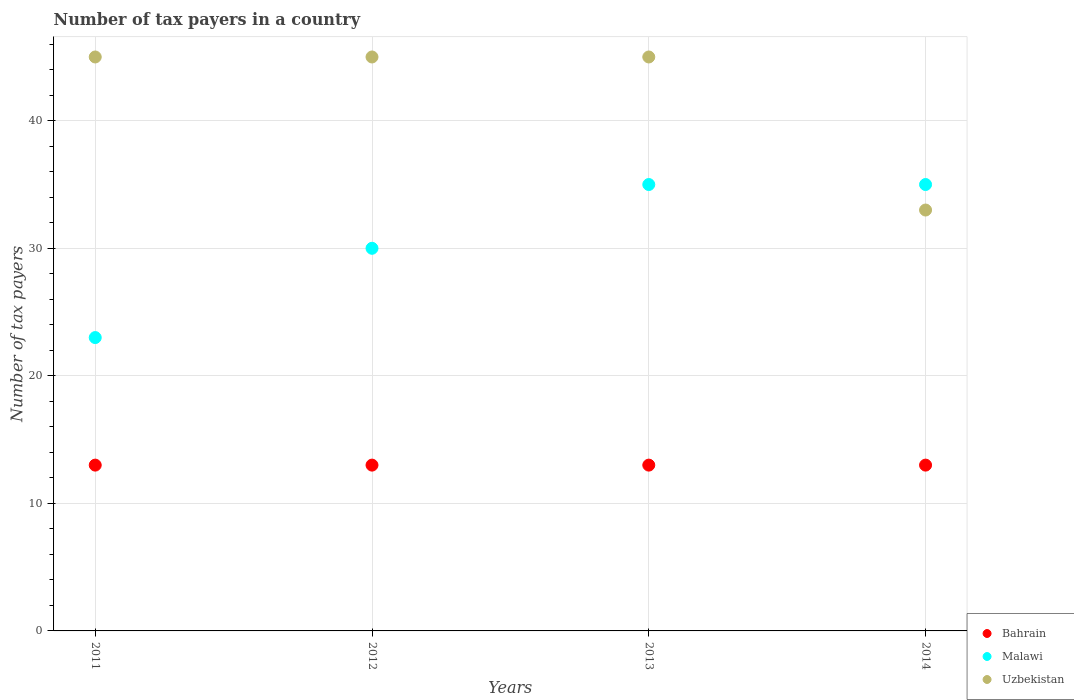How many different coloured dotlines are there?
Keep it short and to the point. 3. Is the number of dotlines equal to the number of legend labels?
Ensure brevity in your answer.  Yes. What is the number of tax payers in in Uzbekistan in 2014?
Ensure brevity in your answer.  33. Across all years, what is the maximum number of tax payers in in Bahrain?
Offer a terse response. 13. Across all years, what is the minimum number of tax payers in in Bahrain?
Offer a terse response. 13. In which year was the number of tax payers in in Uzbekistan minimum?
Make the answer very short. 2014. What is the total number of tax payers in in Malawi in the graph?
Make the answer very short. 123. What is the difference between the number of tax payers in in Bahrain in 2011 and the number of tax payers in in Uzbekistan in 2014?
Offer a very short reply. -20. What is the average number of tax payers in in Uzbekistan per year?
Your response must be concise. 42. In the year 2013, what is the difference between the number of tax payers in in Bahrain and number of tax payers in in Uzbekistan?
Your answer should be very brief. -32. In how many years, is the number of tax payers in in Bahrain greater than 32?
Your response must be concise. 0. What is the ratio of the number of tax payers in in Uzbekistan in 2011 to that in 2014?
Keep it short and to the point. 1.36. Is the difference between the number of tax payers in in Bahrain in 2012 and 2014 greater than the difference between the number of tax payers in in Uzbekistan in 2012 and 2014?
Your answer should be compact. No. What is the difference between the highest and the second highest number of tax payers in in Uzbekistan?
Offer a terse response. 0. What is the difference between the highest and the lowest number of tax payers in in Malawi?
Ensure brevity in your answer.  12. In how many years, is the number of tax payers in in Bahrain greater than the average number of tax payers in in Bahrain taken over all years?
Your answer should be compact. 0. How many dotlines are there?
Offer a terse response. 3. How many years are there in the graph?
Make the answer very short. 4. Does the graph contain any zero values?
Your response must be concise. No. Does the graph contain grids?
Ensure brevity in your answer.  Yes. Where does the legend appear in the graph?
Offer a terse response. Bottom right. What is the title of the graph?
Your response must be concise. Number of tax payers in a country. What is the label or title of the X-axis?
Keep it short and to the point. Years. What is the label or title of the Y-axis?
Your answer should be compact. Number of tax payers. What is the Number of tax payers in Uzbekistan in 2011?
Make the answer very short. 45. What is the Number of tax payers in Malawi in 2012?
Provide a short and direct response. 30. What is the Number of tax payers in Uzbekistan in 2012?
Your response must be concise. 45. What is the Number of tax payers of Uzbekistan in 2014?
Offer a terse response. 33. Across all years, what is the maximum Number of tax payers of Bahrain?
Provide a succinct answer. 13. Across all years, what is the minimum Number of tax payers of Malawi?
Offer a terse response. 23. Across all years, what is the minimum Number of tax payers in Uzbekistan?
Your response must be concise. 33. What is the total Number of tax payers in Bahrain in the graph?
Give a very brief answer. 52. What is the total Number of tax payers in Malawi in the graph?
Ensure brevity in your answer.  123. What is the total Number of tax payers in Uzbekistan in the graph?
Your response must be concise. 168. What is the difference between the Number of tax payers in Bahrain in 2011 and that in 2012?
Keep it short and to the point. 0. What is the difference between the Number of tax payers of Uzbekistan in 2011 and that in 2014?
Give a very brief answer. 12. What is the difference between the Number of tax payers of Bahrain in 2012 and that in 2013?
Give a very brief answer. 0. What is the difference between the Number of tax payers in Uzbekistan in 2012 and that in 2013?
Your response must be concise. 0. What is the difference between the Number of tax payers in Bahrain in 2011 and the Number of tax payers in Uzbekistan in 2012?
Provide a short and direct response. -32. What is the difference between the Number of tax payers of Bahrain in 2011 and the Number of tax payers of Uzbekistan in 2013?
Provide a short and direct response. -32. What is the difference between the Number of tax payers of Malawi in 2011 and the Number of tax payers of Uzbekistan in 2013?
Make the answer very short. -22. What is the difference between the Number of tax payers in Malawi in 2011 and the Number of tax payers in Uzbekistan in 2014?
Offer a very short reply. -10. What is the difference between the Number of tax payers in Bahrain in 2012 and the Number of tax payers in Malawi in 2013?
Your response must be concise. -22. What is the difference between the Number of tax payers of Bahrain in 2012 and the Number of tax payers of Uzbekistan in 2013?
Your response must be concise. -32. What is the difference between the Number of tax payers of Malawi in 2012 and the Number of tax payers of Uzbekistan in 2013?
Your answer should be very brief. -15. What is the difference between the Number of tax payers of Bahrain in 2012 and the Number of tax payers of Malawi in 2014?
Ensure brevity in your answer.  -22. What is the difference between the Number of tax payers of Malawi in 2012 and the Number of tax payers of Uzbekistan in 2014?
Offer a terse response. -3. What is the difference between the Number of tax payers of Bahrain in 2013 and the Number of tax payers of Uzbekistan in 2014?
Your answer should be very brief. -20. What is the average Number of tax payers in Malawi per year?
Ensure brevity in your answer.  30.75. What is the average Number of tax payers of Uzbekistan per year?
Give a very brief answer. 42. In the year 2011, what is the difference between the Number of tax payers in Bahrain and Number of tax payers in Uzbekistan?
Offer a terse response. -32. In the year 2012, what is the difference between the Number of tax payers in Bahrain and Number of tax payers in Uzbekistan?
Your answer should be compact. -32. In the year 2012, what is the difference between the Number of tax payers of Malawi and Number of tax payers of Uzbekistan?
Offer a very short reply. -15. In the year 2013, what is the difference between the Number of tax payers of Bahrain and Number of tax payers of Malawi?
Provide a short and direct response. -22. In the year 2013, what is the difference between the Number of tax payers of Bahrain and Number of tax payers of Uzbekistan?
Make the answer very short. -32. What is the ratio of the Number of tax payers in Malawi in 2011 to that in 2012?
Give a very brief answer. 0.77. What is the ratio of the Number of tax payers of Uzbekistan in 2011 to that in 2012?
Offer a very short reply. 1. What is the ratio of the Number of tax payers in Malawi in 2011 to that in 2013?
Your response must be concise. 0.66. What is the ratio of the Number of tax payers in Uzbekistan in 2011 to that in 2013?
Your answer should be very brief. 1. What is the ratio of the Number of tax payers of Malawi in 2011 to that in 2014?
Your answer should be very brief. 0.66. What is the ratio of the Number of tax payers in Uzbekistan in 2011 to that in 2014?
Offer a terse response. 1.36. What is the ratio of the Number of tax payers in Malawi in 2012 to that in 2013?
Offer a very short reply. 0.86. What is the ratio of the Number of tax payers of Bahrain in 2012 to that in 2014?
Your response must be concise. 1. What is the ratio of the Number of tax payers of Uzbekistan in 2012 to that in 2014?
Give a very brief answer. 1.36. What is the ratio of the Number of tax payers of Uzbekistan in 2013 to that in 2014?
Your response must be concise. 1.36. What is the difference between the highest and the second highest Number of tax payers of Bahrain?
Keep it short and to the point. 0. What is the difference between the highest and the lowest Number of tax payers in Bahrain?
Ensure brevity in your answer.  0. What is the difference between the highest and the lowest Number of tax payers in Malawi?
Give a very brief answer. 12. What is the difference between the highest and the lowest Number of tax payers of Uzbekistan?
Provide a succinct answer. 12. 